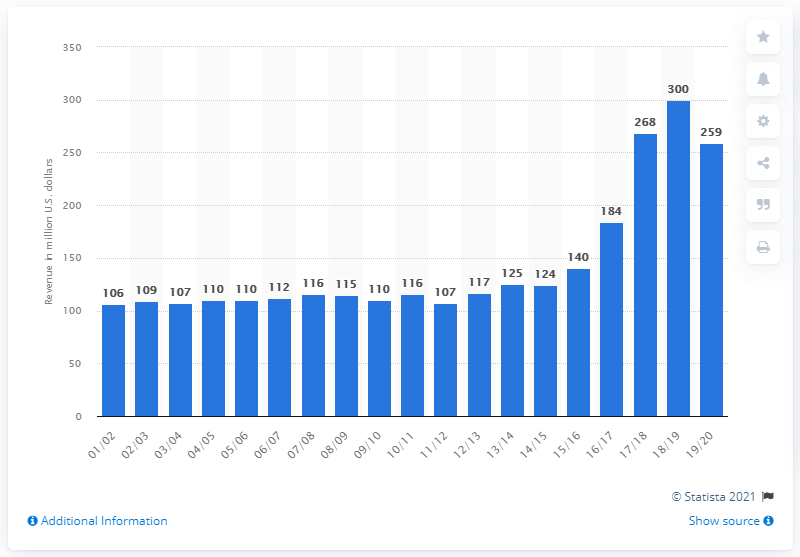Point out several critical features in this image. The estimated revenue of the National Basketball Association in the 2019/2020 fiscal year was 259 billion dollars. 